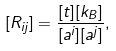Convert formula to latex. <formula><loc_0><loc_0><loc_500><loc_500>[ R _ { i j } ] = \frac { [ t ] [ k _ { B } ] } { [ a ^ { i } ] [ a ^ { j } ] } ,</formula> 